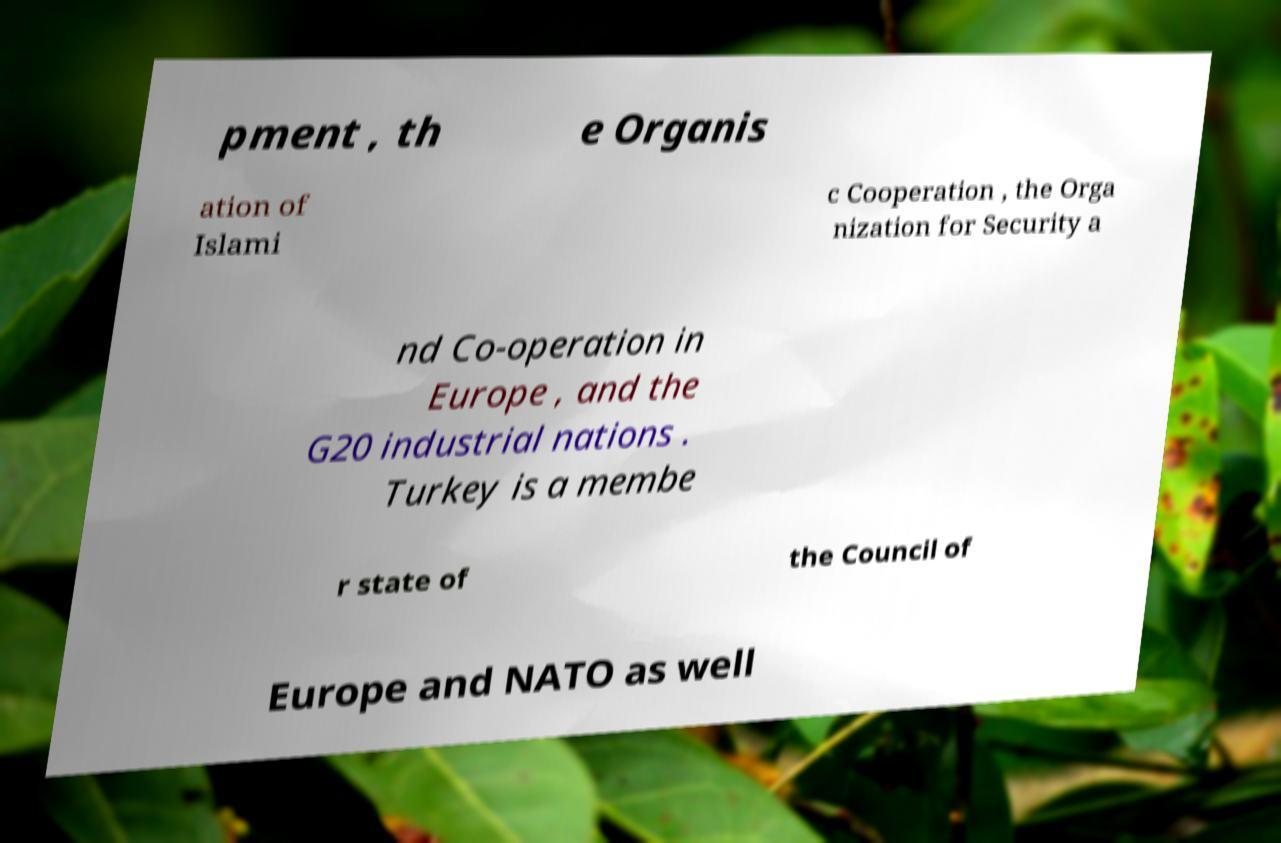Can you read and provide the text displayed in the image?This photo seems to have some interesting text. Can you extract and type it out for me? pment , th e Organis ation of Islami c Cooperation , the Orga nization for Security a nd Co-operation in Europe , and the G20 industrial nations . Turkey is a membe r state of the Council of Europe and NATO as well 